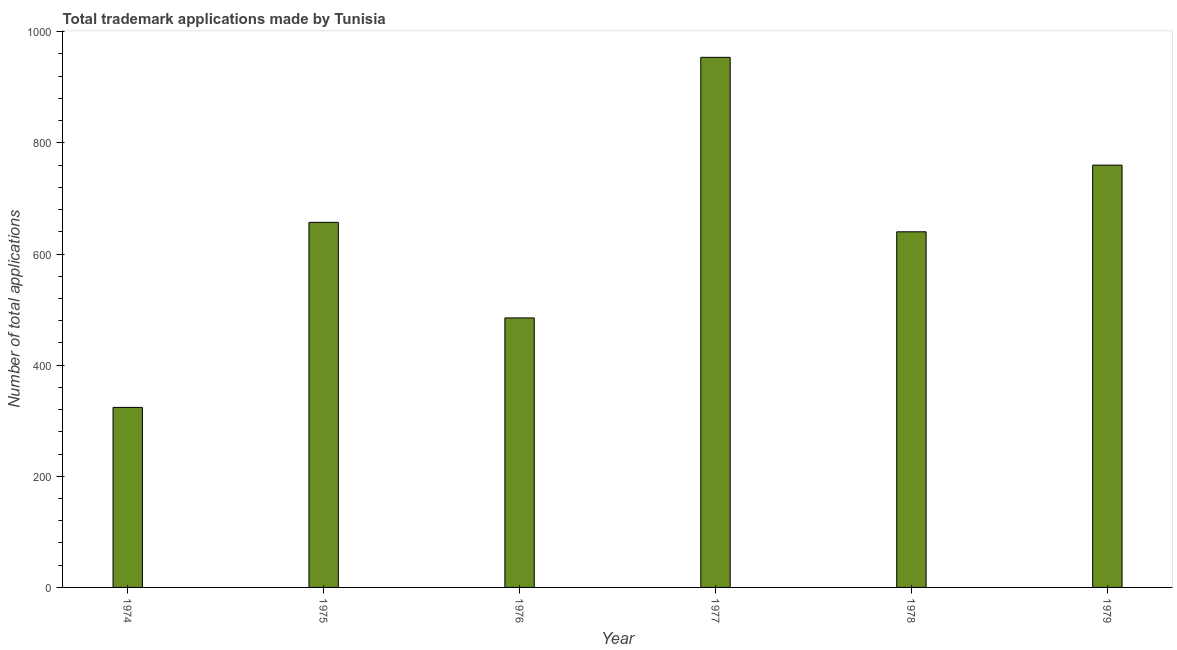Does the graph contain any zero values?
Your response must be concise. No. Does the graph contain grids?
Offer a terse response. No. What is the title of the graph?
Ensure brevity in your answer.  Total trademark applications made by Tunisia. What is the label or title of the Y-axis?
Your answer should be compact. Number of total applications. What is the number of trademark applications in 1974?
Make the answer very short. 324. Across all years, what is the maximum number of trademark applications?
Your response must be concise. 954. Across all years, what is the minimum number of trademark applications?
Ensure brevity in your answer.  324. In which year was the number of trademark applications minimum?
Offer a very short reply. 1974. What is the sum of the number of trademark applications?
Keep it short and to the point. 3820. What is the difference between the number of trademark applications in 1974 and 1975?
Give a very brief answer. -333. What is the average number of trademark applications per year?
Keep it short and to the point. 636. What is the median number of trademark applications?
Keep it short and to the point. 648.5. In how many years, is the number of trademark applications greater than 360 ?
Make the answer very short. 5. Do a majority of the years between 1977 and 1976 (inclusive) have number of trademark applications greater than 720 ?
Offer a very short reply. No. What is the ratio of the number of trademark applications in 1974 to that in 1977?
Offer a very short reply. 0.34. What is the difference between the highest and the second highest number of trademark applications?
Provide a succinct answer. 194. Is the sum of the number of trademark applications in 1976 and 1978 greater than the maximum number of trademark applications across all years?
Keep it short and to the point. Yes. What is the difference between the highest and the lowest number of trademark applications?
Give a very brief answer. 630. In how many years, is the number of trademark applications greater than the average number of trademark applications taken over all years?
Make the answer very short. 4. How many bars are there?
Make the answer very short. 6. What is the difference between two consecutive major ticks on the Y-axis?
Your answer should be compact. 200. What is the Number of total applications of 1974?
Offer a very short reply. 324. What is the Number of total applications of 1975?
Offer a very short reply. 657. What is the Number of total applications in 1976?
Provide a short and direct response. 485. What is the Number of total applications of 1977?
Provide a succinct answer. 954. What is the Number of total applications in 1978?
Provide a short and direct response. 640. What is the Number of total applications in 1979?
Ensure brevity in your answer.  760. What is the difference between the Number of total applications in 1974 and 1975?
Make the answer very short. -333. What is the difference between the Number of total applications in 1974 and 1976?
Offer a terse response. -161. What is the difference between the Number of total applications in 1974 and 1977?
Provide a succinct answer. -630. What is the difference between the Number of total applications in 1974 and 1978?
Keep it short and to the point. -316. What is the difference between the Number of total applications in 1974 and 1979?
Your response must be concise. -436. What is the difference between the Number of total applications in 1975 and 1976?
Ensure brevity in your answer.  172. What is the difference between the Number of total applications in 1975 and 1977?
Ensure brevity in your answer.  -297. What is the difference between the Number of total applications in 1975 and 1978?
Make the answer very short. 17. What is the difference between the Number of total applications in 1975 and 1979?
Your response must be concise. -103. What is the difference between the Number of total applications in 1976 and 1977?
Give a very brief answer. -469. What is the difference between the Number of total applications in 1976 and 1978?
Keep it short and to the point. -155. What is the difference between the Number of total applications in 1976 and 1979?
Offer a terse response. -275. What is the difference between the Number of total applications in 1977 and 1978?
Ensure brevity in your answer.  314. What is the difference between the Number of total applications in 1977 and 1979?
Offer a very short reply. 194. What is the difference between the Number of total applications in 1978 and 1979?
Your answer should be compact. -120. What is the ratio of the Number of total applications in 1974 to that in 1975?
Make the answer very short. 0.49. What is the ratio of the Number of total applications in 1974 to that in 1976?
Ensure brevity in your answer.  0.67. What is the ratio of the Number of total applications in 1974 to that in 1977?
Give a very brief answer. 0.34. What is the ratio of the Number of total applications in 1974 to that in 1978?
Make the answer very short. 0.51. What is the ratio of the Number of total applications in 1974 to that in 1979?
Your answer should be very brief. 0.43. What is the ratio of the Number of total applications in 1975 to that in 1976?
Provide a succinct answer. 1.35. What is the ratio of the Number of total applications in 1975 to that in 1977?
Your answer should be compact. 0.69. What is the ratio of the Number of total applications in 1975 to that in 1979?
Provide a short and direct response. 0.86. What is the ratio of the Number of total applications in 1976 to that in 1977?
Make the answer very short. 0.51. What is the ratio of the Number of total applications in 1976 to that in 1978?
Give a very brief answer. 0.76. What is the ratio of the Number of total applications in 1976 to that in 1979?
Give a very brief answer. 0.64. What is the ratio of the Number of total applications in 1977 to that in 1978?
Give a very brief answer. 1.49. What is the ratio of the Number of total applications in 1977 to that in 1979?
Your answer should be very brief. 1.25. What is the ratio of the Number of total applications in 1978 to that in 1979?
Provide a succinct answer. 0.84. 